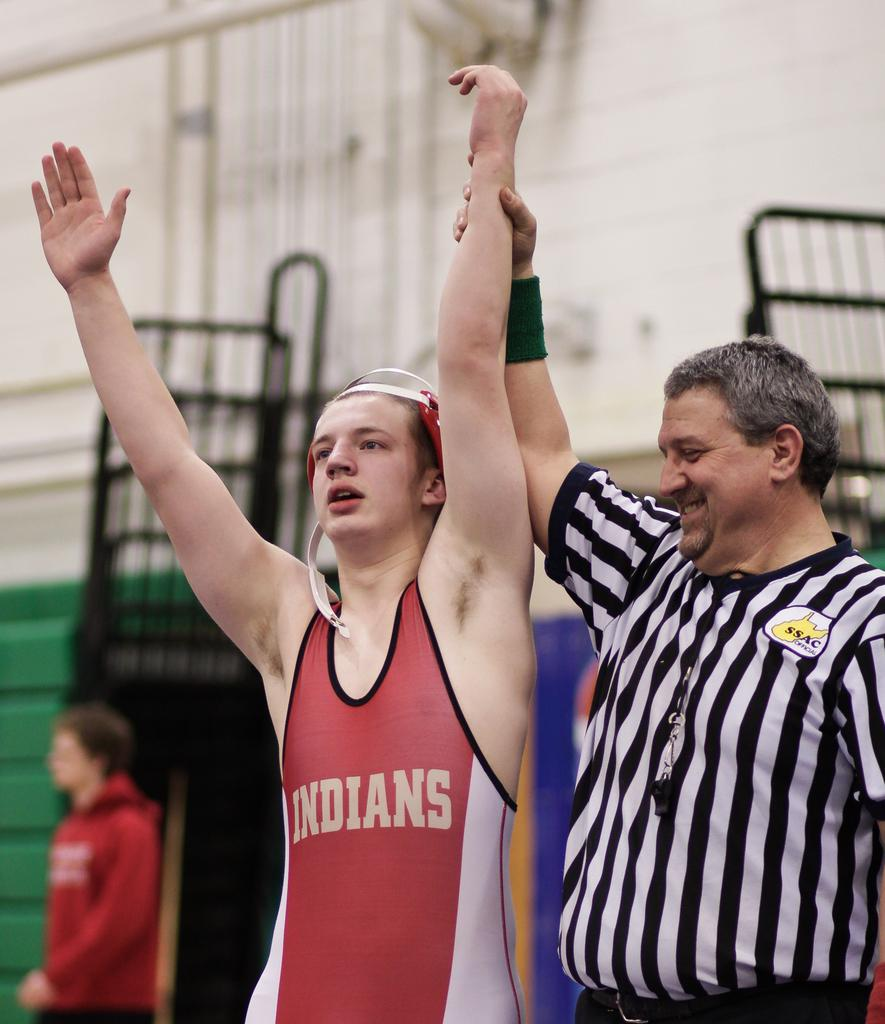Provide a one-sentence caption for the provided image. ssac official holds up hand of indians wrestler. 